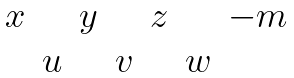Convert formula to latex. <formula><loc_0><loc_0><loc_500><loc_500>\begin{matrix} x & & y & & z & & - m \\ & u & & v & & w \end{matrix}</formula> 